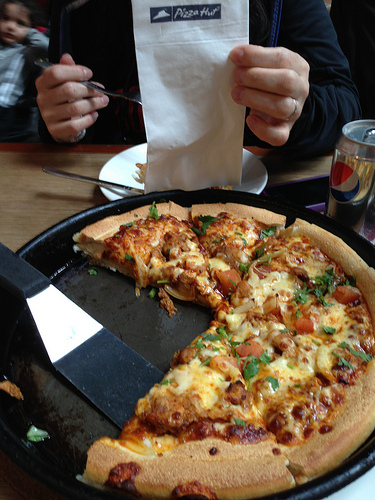Please provide a short description for this region: [0.78, 0.32, 0.84, 0.41]. This region contains the logo of Pepsi, which is visible on the can. 